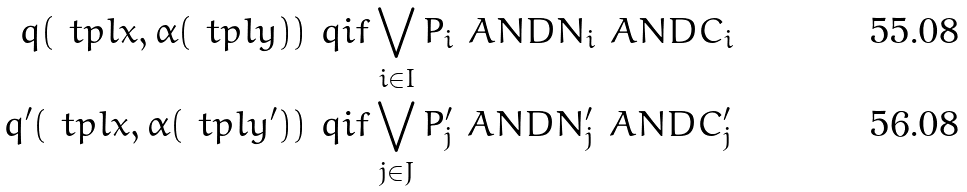<formula> <loc_0><loc_0><loc_500><loc_500>q ( \ t p l x , \alpha ( \ t p l y ) ) & \ q i f \bigvee _ { i \in I } P _ { i } \ A N D N _ { i } \ A N D C _ { i } \\ q ^ { \prime } ( \ t p l x , \alpha ( \ t p l y ^ { \prime } ) ) & \ q i f \bigvee _ { j \in J } P ^ { \prime } _ { j } \ A N D N ^ { \prime } _ { j } \ A N D C ^ { \prime } _ { j }</formula> 